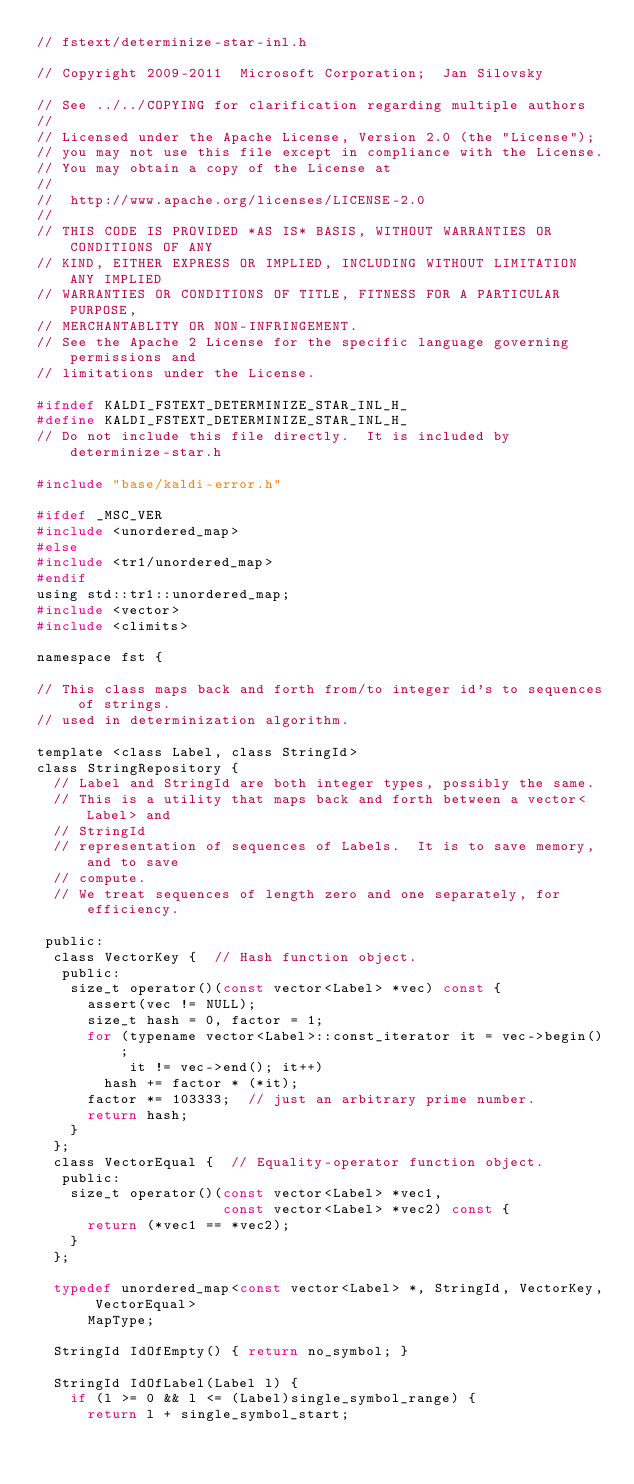<code> <loc_0><loc_0><loc_500><loc_500><_C_>// fstext/determinize-star-inl.h

// Copyright 2009-2011  Microsoft Corporation;  Jan Silovsky

// See ../../COPYING for clarification regarding multiple authors
//
// Licensed under the Apache License, Version 2.0 (the "License");
// you may not use this file except in compliance with the License.
// You may obtain a copy of the License at
//
//  http://www.apache.org/licenses/LICENSE-2.0
//
// THIS CODE IS PROVIDED *AS IS* BASIS, WITHOUT WARRANTIES OR CONDITIONS OF ANY
// KIND, EITHER EXPRESS OR IMPLIED, INCLUDING WITHOUT LIMITATION ANY IMPLIED
// WARRANTIES OR CONDITIONS OF TITLE, FITNESS FOR A PARTICULAR PURPOSE,
// MERCHANTABLITY OR NON-INFRINGEMENT.
// See the Apache 2 License for the specific language governing permissions and
// limitations under the License.

#ifndef KALDI_FSTEXT_DETERMINIZE_STAR_INL_H_
#define KALDI_FSTEXT_DETERMINIZE_STAR_INL_H_
// Do not include this file directly.  It is included by determinize-star.h

#include "base/kaldi-error.h"

#ifdef _MSC_VER
#include <unordered_map>
#else
#include <tr1/unordered_map>
#endif
using std::tr1::unordered_map;
#include <vector>
#include <climits>

namespace fst {

// This class maps back and forth from/to integer id's to sequences of strings.
// used in determinization algorithm.

template <class Label, class StringId>
class StringRepository {
  // Label and StringId are both integer types, possibly the same.
  // This is a utility that maps back and forth between a vector<Label> and
  // StringId
  // representation of sequences of Labels.  It is to save memory, and to save
  // compute.
  // We treat sequences of length zero and one separately, for efficiency.

 public:
  class VectorKey {  // Hash function object.
   public:
    size_t operator()(const vector<Label> *vec) const {
      assert(vec != NULL);
      size_t hash = 0, factor = 1;
      for (typename vector<Label>::const_iterator it = vec->begin();
           it != vec->end(); it++)
        hash += factor * (*it);
      factor *= 103333;  // just an arbitrary prime number.
      return hash;
    }
  };
  class VectorEqual {  // Equality-operator function object.
   public:
    size_t operator()(const vector<Label> *vec1,
                      const vector<Label> *vec2) const {
      return (*vec1 == *vec2);
    }
  };

  typedef unordered_map<const vector<Label> *, StringId, VectorKey, VectorEqual>
      MapType;

  StringId IdOfEmpty() { return no_symbol; }

  StringId IdOfLabel(Label l) {
    if (l >= 0 && l <= (Label)single_symbol_range) {
      return l + single_symbol_start;</code> 